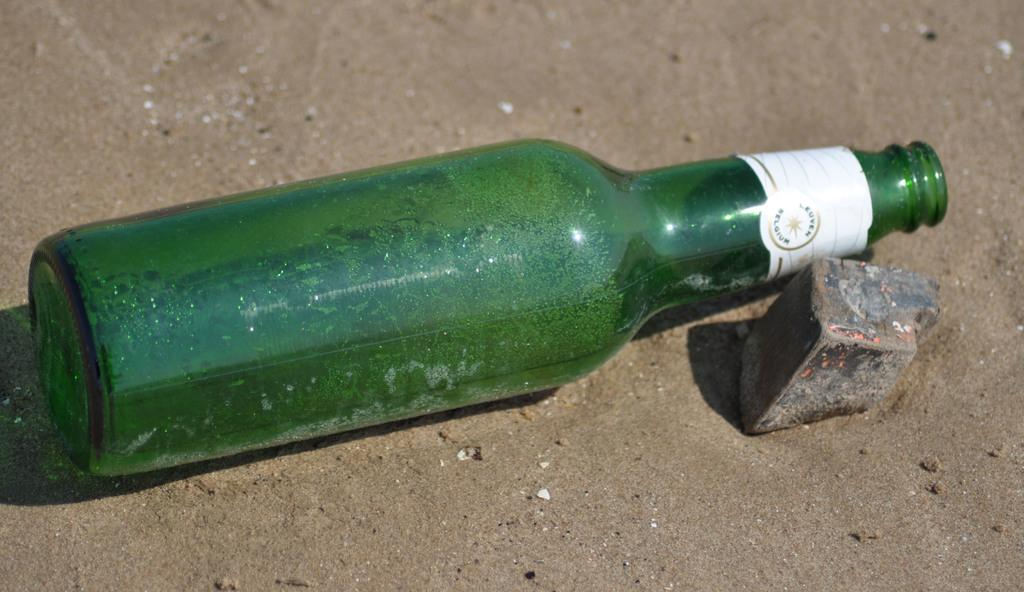What is the main object in the image? There is a wine bottle in the image. How is the wine bottle positioned on the ground? The wine bottle is tilted down on the ground. What color is the wine bottle? The wine bottle is green in color. Are there any other objects near the wine bottle? Yes, there is a stone beside the wine bottle. What type of relation does the minister have with the wine bottle in the image? There is no minister present in the image, so it is not possible to determine any relation. 